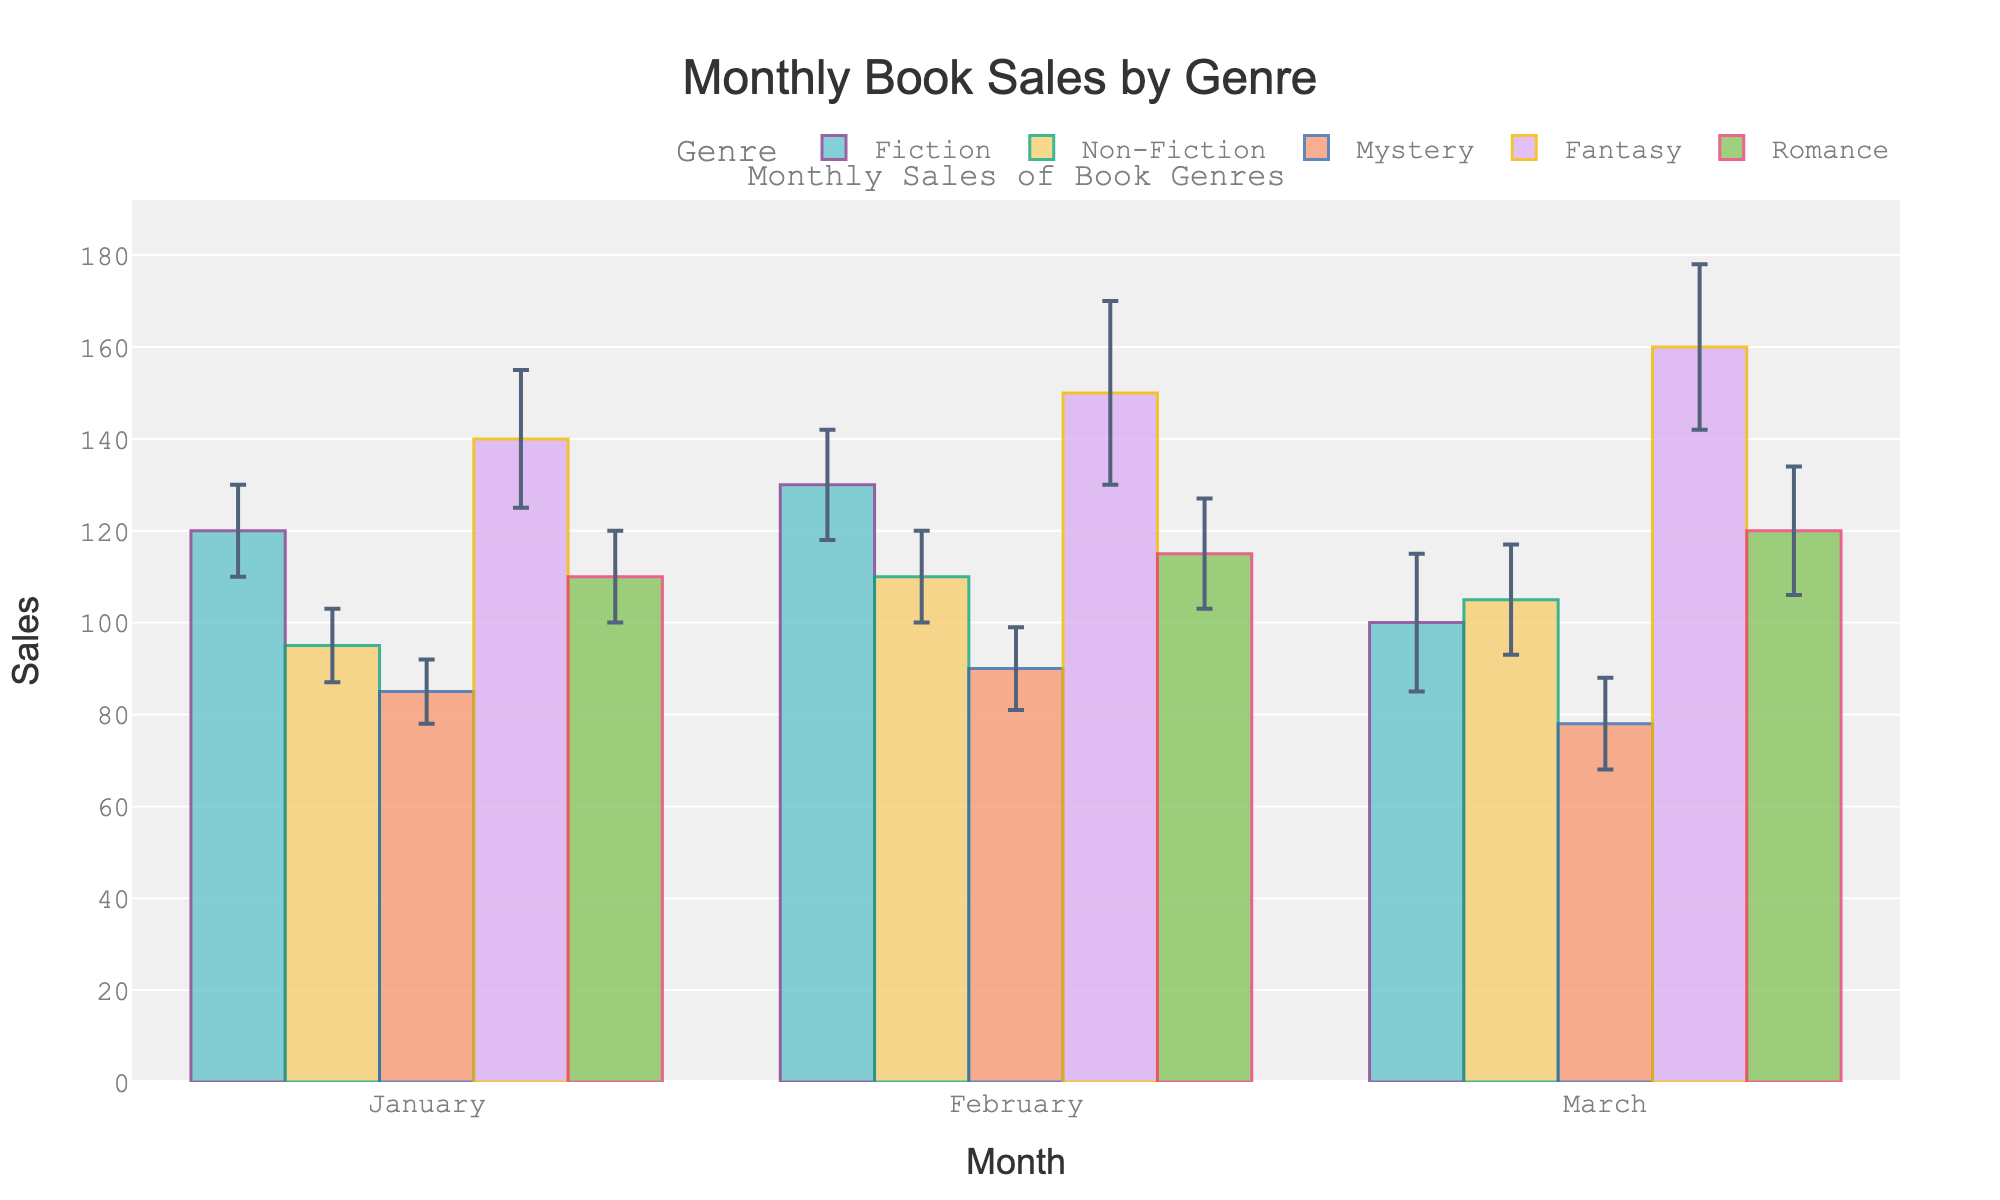What is the title of the bar chart? The title of the bar chart is displayed at the top and reads "Monthly Book Sales by Genre".
Answer: Monthly Book Sales by Genre Which genre had the highest sales in March? By looking at the heights of the bars for March, the Fantasy genre had the highest sales.
Answer: Fantasy How many genres are compared in this bar chart? By counting the distinct color bars in each month, we see five genres being compared: Fiction, Non-Fiction, Mystery, Fantasy, and Romance.
Answer: Five What is the sales value and error margin for Romance in February? The bar chart shows that for Romance in February, the sales value is 115 with an error margin indicated by the error bar (±12).
Answer: 115 and ±12 Which month shows the highest sales variability for any genre? By comparing the error bars (the vertical lines on each bar), February shows the highest sales variability in the Fantasy genre with an error margin of ±20.
Answer: February Which genre experienced the lowest sales in January? By comparing the heights of the bars in January, Mystery had the lowest sales.
Answer: Mystery What is the average sales value for the Fiction genre over the three months? Adding Fiction sales for January (120), February (130), and March (100) gives a total of 350. The average is 350 divided by 3.
Answer: 116.67 How do the sales of Fantasy compare between January and March? The sales for Fantasy in January are 140 and in March are 160, showing an increase of 20 sales units from January to March.
Answer: Increased by 20 Which genre had consistently decreasing sales from January to March? Mystery had decreasing sales values: January (85), February (90), and March (78), showing a consistent decline.
Answer: Mystery What is the difference in sales between Fiction and Non-Fiction in February? The sales for Fiction in February are 130 and Non-Fiction are 110. The difference is 130 - 110 = 20.
Answer: 20 